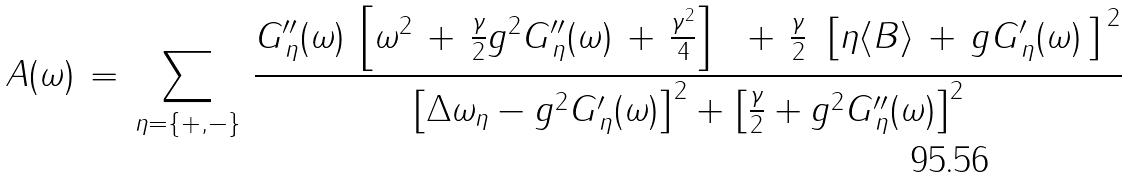<formula> <loc_0><loc_0><loc_500><loc_500>A ( \omega ) \, = \, \sum _ { \eta = \{ + , - \} } \, \frac { G ^ { \prime \prime } _ { \, \eta } ( \omega ) \, \left [ \omega ^ { 2 } \, + \, \frac { \gamma } { 2 } g ^ { 2 } G ^ { \prime \prime } _ { \, \eta } ( \omega ) \, + \, \frac { \gamma ^ { 2 } } { 4 } \right ] \, { \, } { \, } + \, \frac { \gamma } { 2 } \, { \, } \left [ \eta \langle B \rangle \, + \, g G ^ { \prime } _ { \, \eta } ( \omega ) { \, } \right ] ^ { { \, } 2 } } { \left [ \Delta \omega _ { \eta } - g ^ { 2 } G ^ { \prime } _ { \, \eta } ( \omega ) \right ] ^ { 2 } + \left [ \frac { \gamma } { 2 } + g ^ { 2 } G ^ { \prime \prime } _ { \, \eta } ( \omega ) \right ] ^ { 2 } }</formula> 